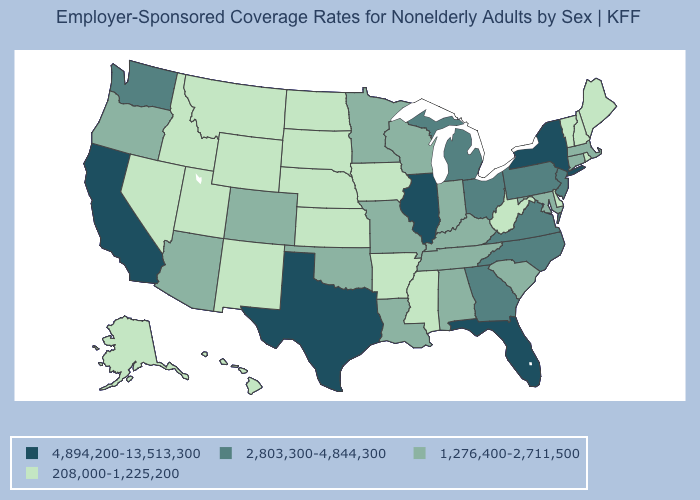What is the value of Illinois?
Write a very short answer. 4,894,200-13,513,300. Which states have the lowest value in the USA?
Be succinct. Alaska, Arkansas, Delaware, Hawaii, Idaho, Iowa, Kansas, Maine, Mississippi, Montana, Nebraska, Nevada, New Hampshire, New Mexico, North Dakota, Rhode Island, South Dakota, Utah, Vermont, West Virginia, Wyoming. What is the value of Texas?
Quick response, please. 4,894,200-13,513,300. What is the lowest value in the USA?
Be succinct. 208,000-1,225,200. What is the value of Utah?
Give a very brief answer. 208,000-1,225,200. Does Florida have the lowest value in the South?
Answer briefly. No. Does Illinois have the highest value in the MidWest?
Be succinct. Yes. Which states have the lowest value in the Northeast?
Concise answer only. Maine, New Hampshire, Rhode Island, Vermont. What is the highest value in states that border Maryland?
Answer briefly. 2,803,300-4,844,300. Does Kentucky have the lowest value in the USA?
Answer briefly. No. Which states have the lowest value in the USA?
Answer briefly. Alaska, Arkansas, Delaware, Hawaii, Idaho, Iowa, Kansas, Maine, Mississippi, Montana, Nebraska, Nevada, New Hampshire, New Mexico, North Dakota, Rhode Island, South Dakota, Utah, Vermont, West Virginia, Wyoming. Does Michigan have a lower value than Hawaii?
Keep it brief. No. Name the states that have a value in the range 1,276,400-2,711,500?
Short answer required. Alabama, Arizona, Colorado, Connecticut, Indiana, Kentucky, Louisiana, Maryland, Massachusetts, Minnesota, Missouri, Oklahoma, Oregon, South Carolina, Tennessee, Wisconsin. Does the map have missing data?
Short answer required. No. 